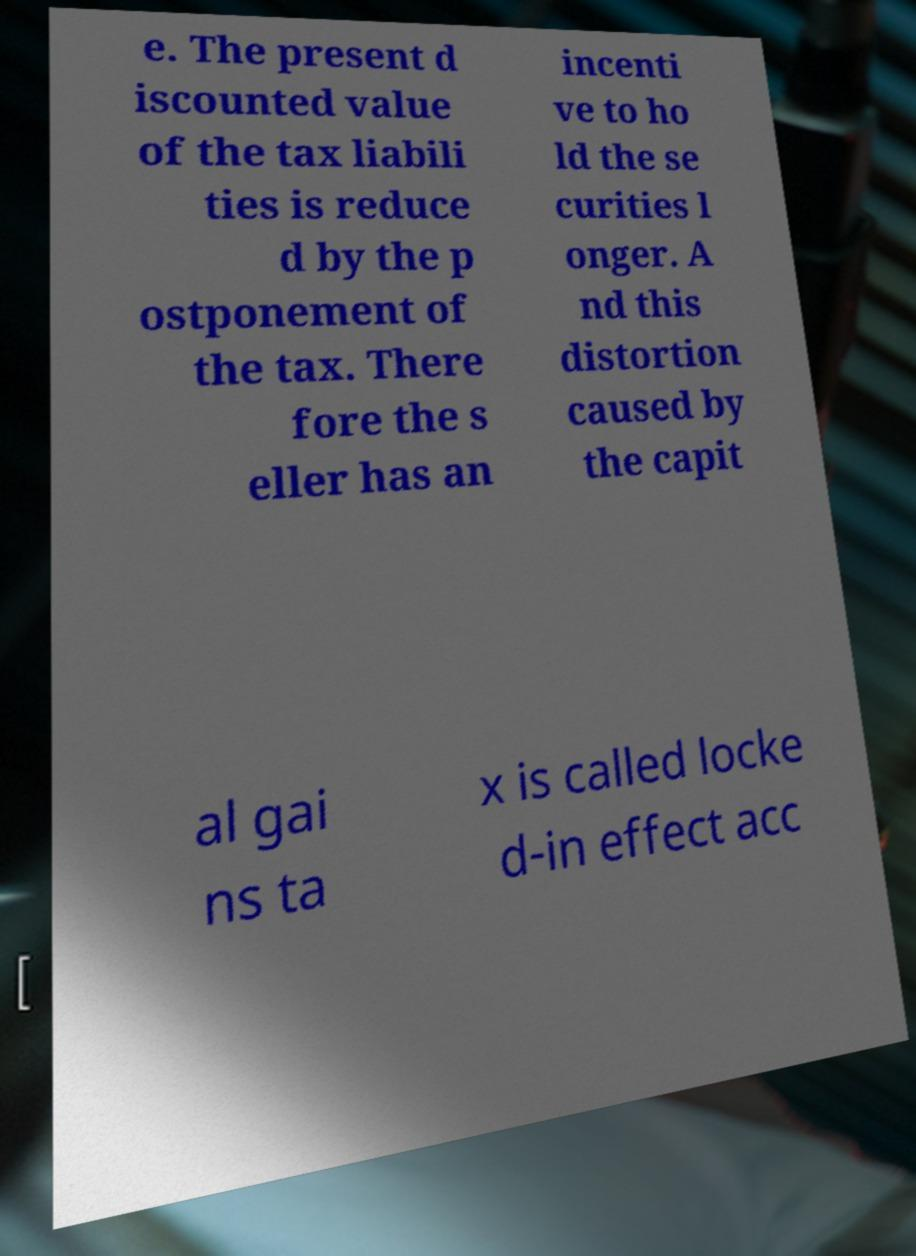There's text embedded in this image that I need extracted. Can you transcribe it verbatim? e. The present d iscounted value of the tax liabili ties is reduce d by the p ostponement of the tax. There fore the s eller has an incenti ve to ho ld the se curities l onger. A nd this distortion caused by the capit al gai ns ta x is called locke d-in effect acc 